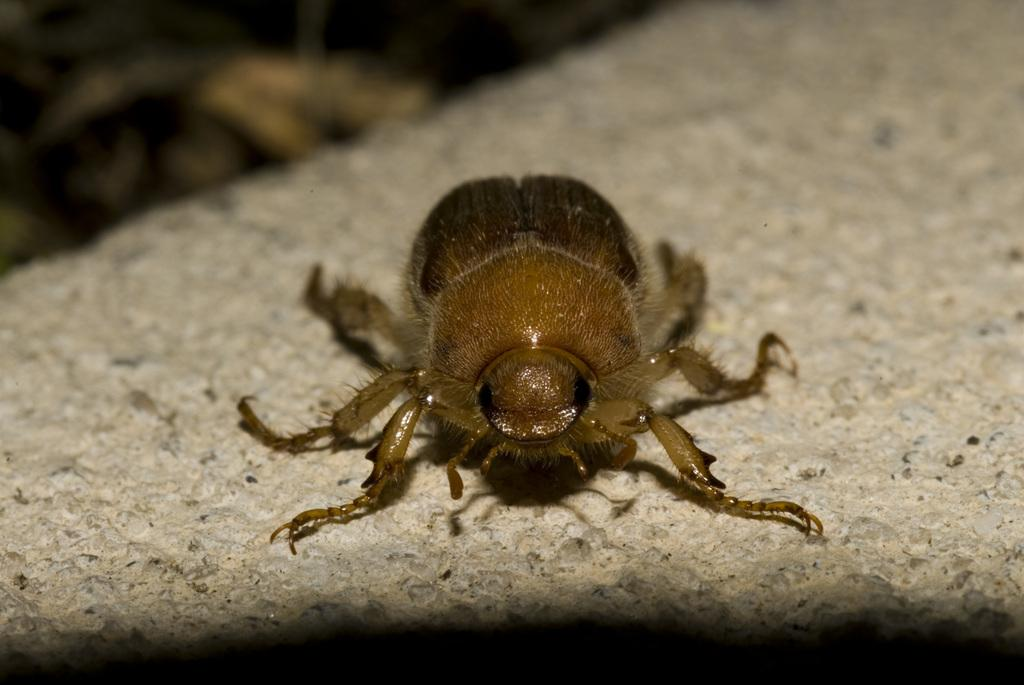What is located in the foreground of the picture? There is an insect in the foreground of the picture. Can you describe the insect's position in relation to its surroundings? The insect is on the surface. What type of coal can be seen being used in the garden during the rainstorm in the image? There is no coal or garden present in the image, and therefore no such activity can be observed. 